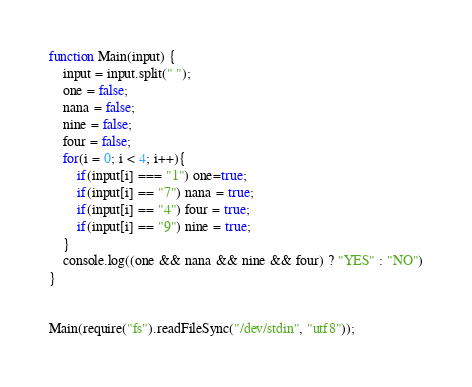Convert code to text. <code><loc_0><loc_0><loc_500><loc_500><_JavaScript_>function Main(input) {
    input = input.split(" ");
    one = false;
    nana = false;
    nine = false;
    four = false;
    for(i = 0; i < 4; i++){
        if(input[i] === "1") one=true;
        if(input[i] == "7") nana = true;
        if(input[i] == "4") four = true;
        if(input[i] == "9") nine = true;
    }
    console.log((one && nana && nine && four) ? "YES" : "NO")
}


Main(require("fs").readFileSync("/dev/stdin", "utf8"));</code> 